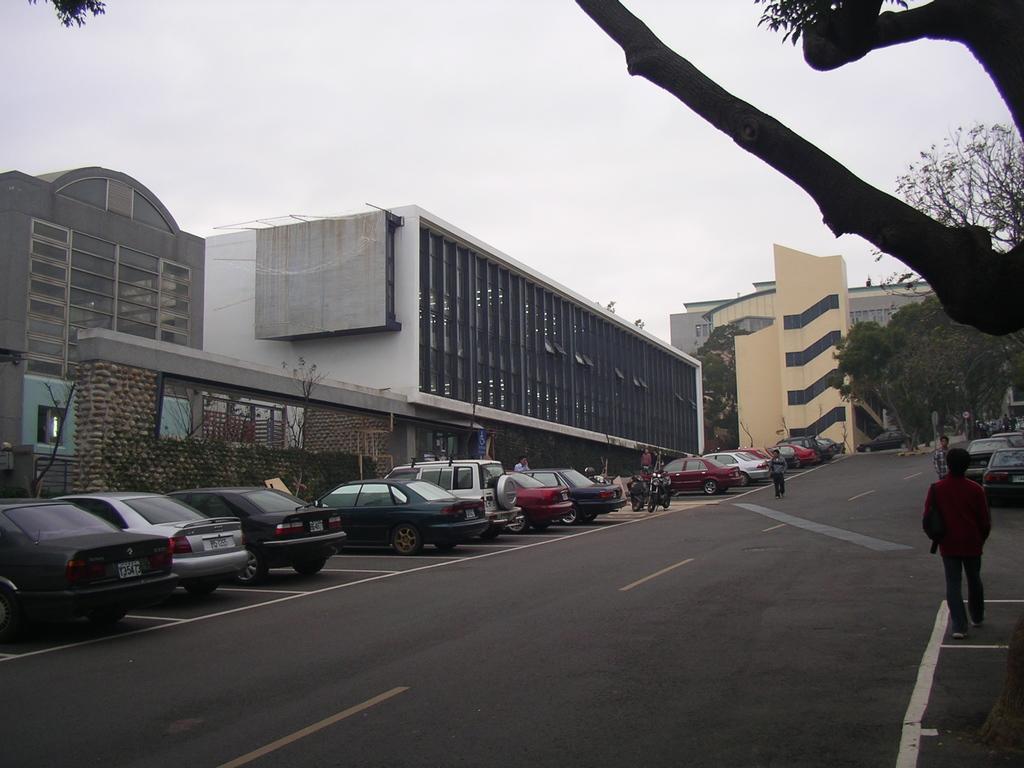Could you give a brief overview of what you see in this image? In the middle of the image we can see some vehicles, motorcycles on the road and few people are walking. Behind them we can see some buildings, trees and plants. At the top of the image we can see some clouds in the sky. 